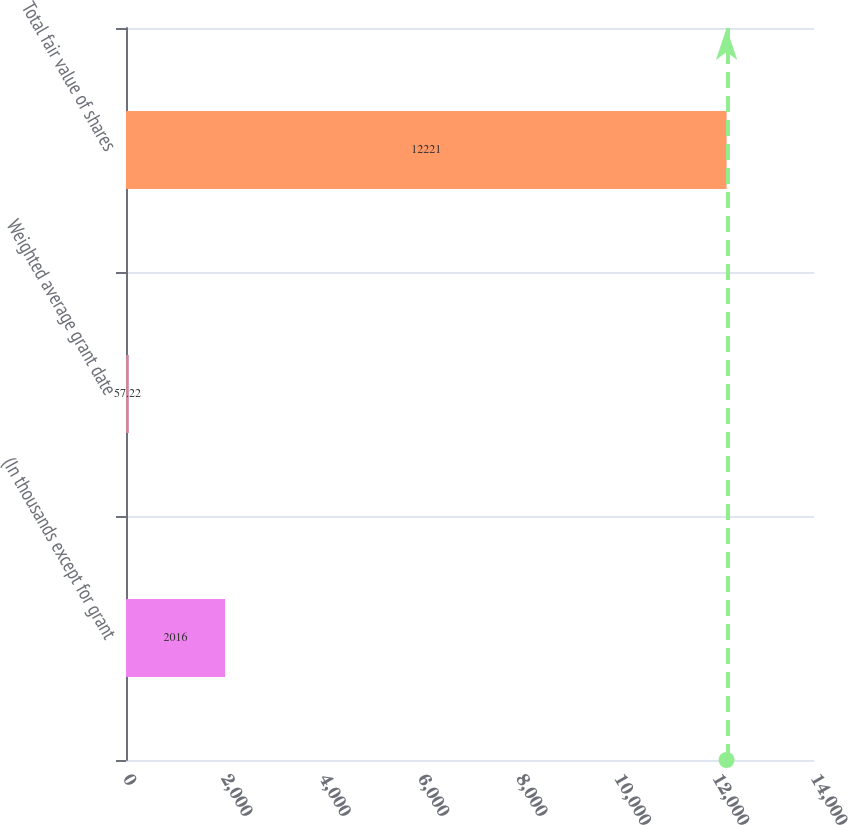<chart> <loc_0><loc_0><loc_500><loc_500><bar_chart><fcel>(In thousands except for grant<fcel>Weighted average grant date<fcel>Total fair value of shares<nl><fcel>2016<fcel>57.22<fcel>12221<nl></chart> 